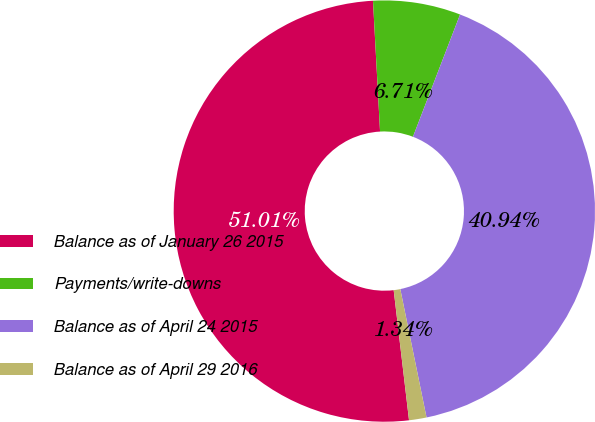Convert chart. <chart><loc_0><loc_0><loc_500><loc_500><pie_chart><fcel>Balance as of January 26 2015<fcel>Payments/write-downs<fcel>Balance as of April 24 2015<fcel>Balance as of April 29 2016<nl><fcel>51.01%<fcel>6.71%<fcel>40.94%<fcel>1.34%<nl></chart> 